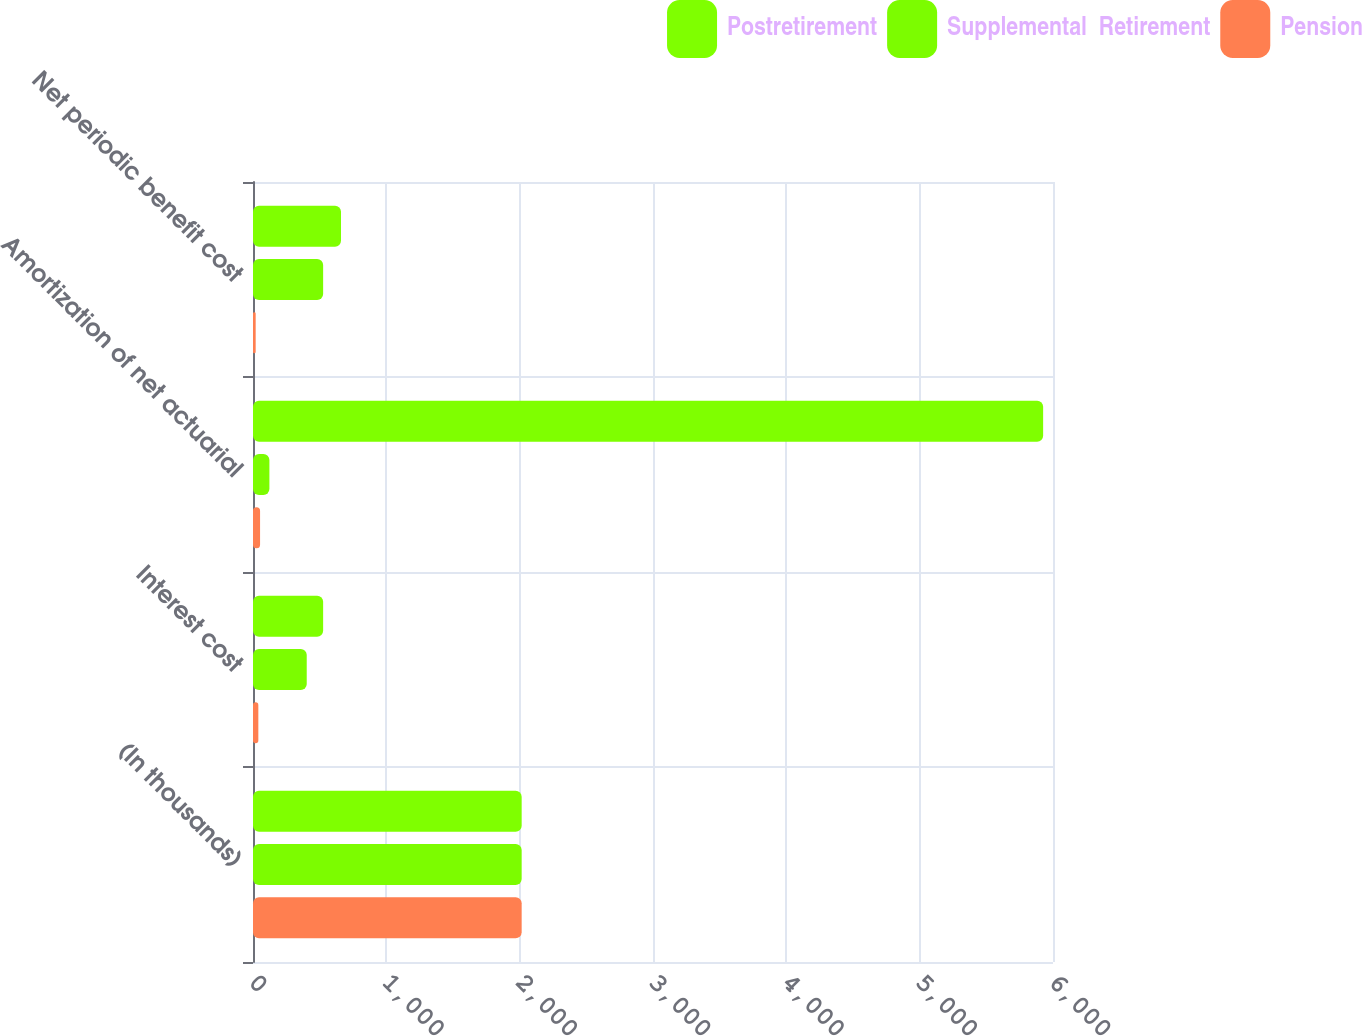Convert chart. <chart><loc_0><loc_0><loc_500><loc_500><stacked_bar_chart><ecel><fcel>(In thousands)<fcel>Interest cost<fcel>Amortization of net actuarial<fcel>Net periodic benefit cost<nl><fcel>Postretirement<fcel>2015<fcel>526<fcel>5926<fcel>660<nl><fcel>Supplemental  Retirement<fcel>2015<fcel>403<fcel>123<fcel>526<nl><fcel>Pension<fcel>2015<fcel>40<fcel>53<fcel>20<nl></chart> 